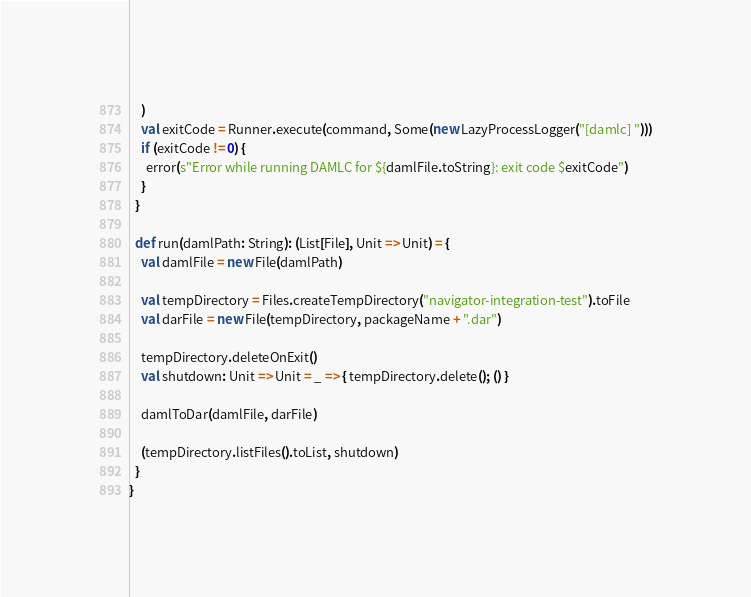<code> <loc_0><loc_0><loc_500><loc_500><_Scala_>    )
    val exitCode = Runner.execute(command, Some(new LazyProcessLogger("[damlc] ")))
    if (exitCode != 0) {
      error(s"Error while running DAMLC for ${damlFile.toString}: exit code $exitCode")
    }
  }

  def run(damlPath: String): (List[File], Unit => Unit) = {
    val damlFile = new File(damlPath)

    val tempDirectory = Files.createTempDirectory("navigator-integration-test").toFile
    val darFile = new File(tempDirectory, packageName + ".dar")

    tempDirectory.deleteOnExit()
    val shutdown: Unit => Unit = _ => { tempDirectory.delete(); () }

    damlToDar(damlFile, darFile)

    (tempDirectory.listFiles().toList, shutdown)
  }
}
</code> 